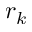Convert formula to latex. <formula><loc_0><loc_0><loc_500><loc_500>r _ { k }</formula> 